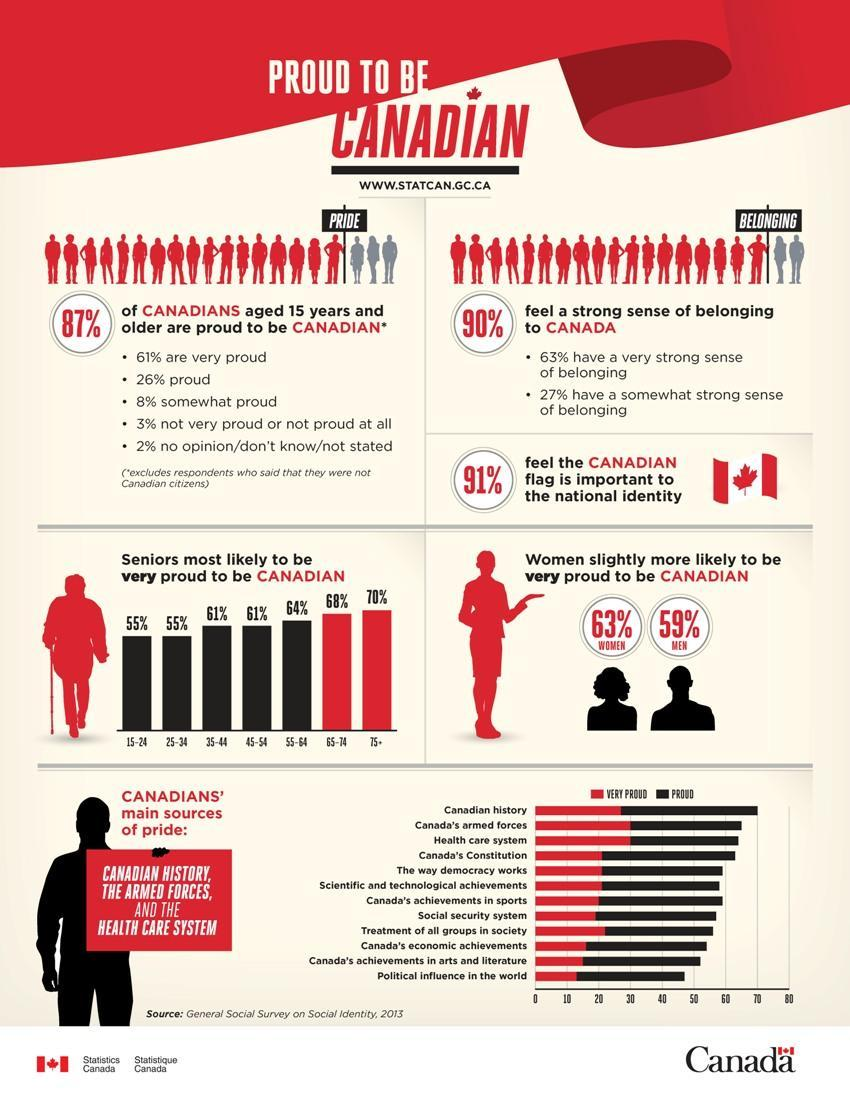What percent of respondents do not feel the Canadian flag is important to the national identity as per the Survey in 2013?
Answer the question with a short phrase. 9% What percent of respondents in the age group of 25-34 years old are proud to be Canadian as per the Survey in 2013? 55% What percentage of women felt very proud to be Canadian according to the General Social Survey on Social Identity in 2013? 63% 